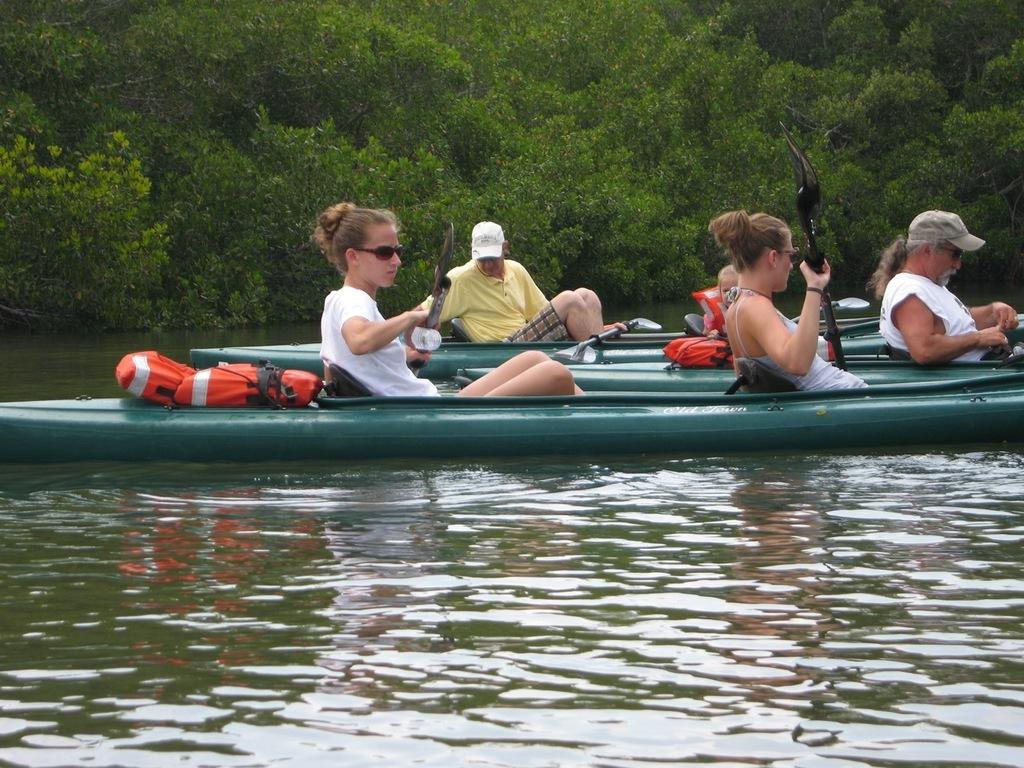What are the people in the image doing? The people in the image are on a boat. What is the boat doing in the image? The boat is sailing on water. What can be seen in the background of the image? There are trees in the background of the image. What type of development can be seen taking place on the street in the image? There is no street present in the image; it features a boat sailing on water with trees in the background. 